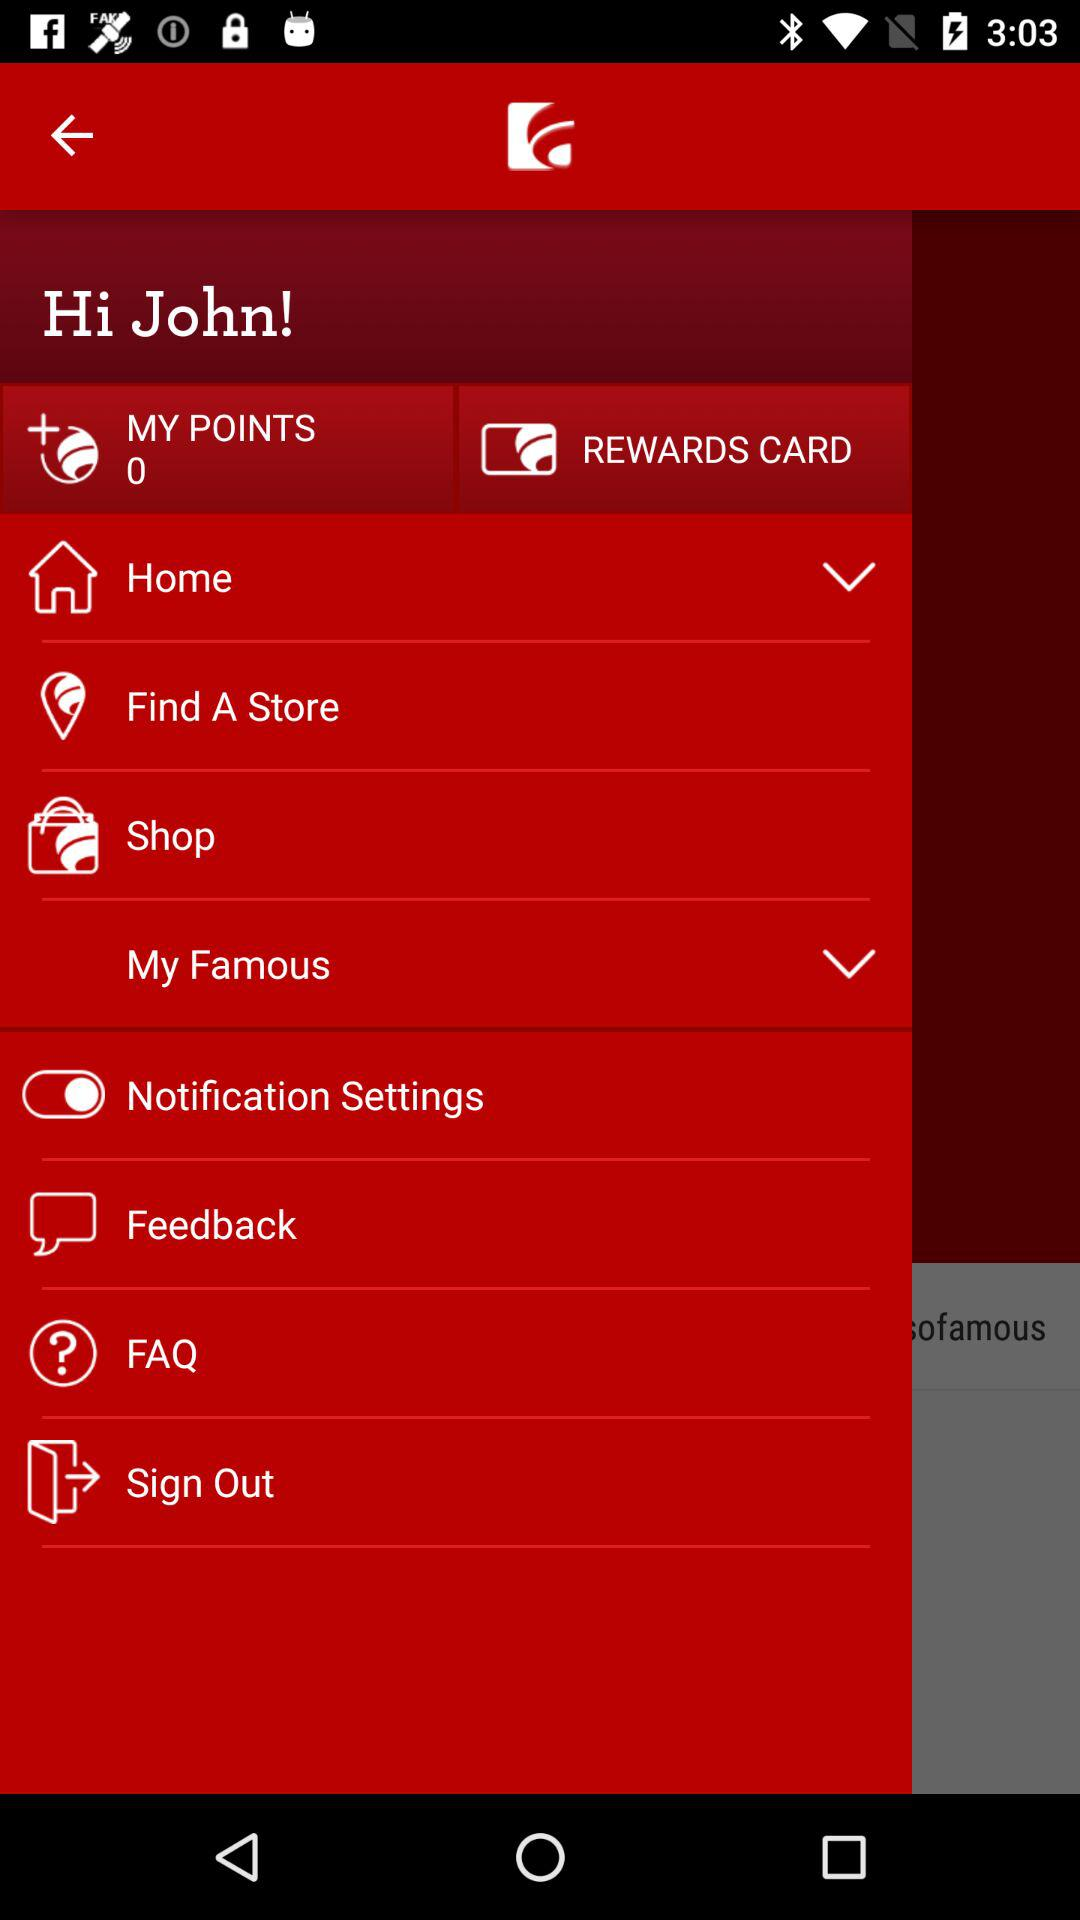How many points are there? There are 0 points. 